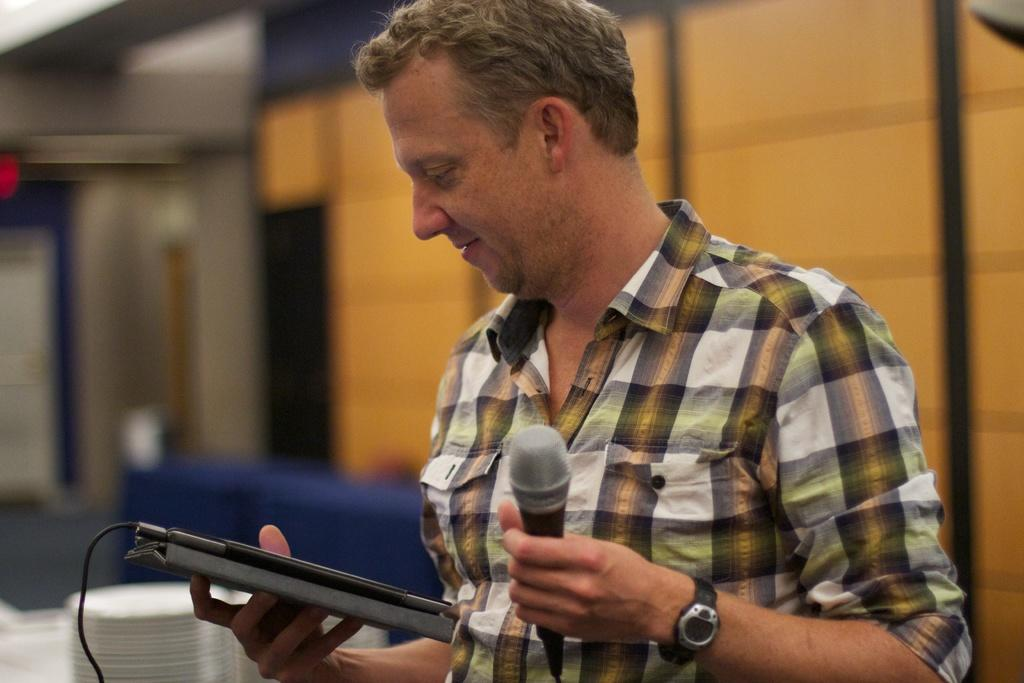What is the main subject of the image? There is a person in the image. Can you describe the person's clothing? The person is wearing a checked shirt. What is the person holding in their left hand? The person is holding a microphone in their left hand. What is the person holding in their right hand? The person is holding an electronic gadget in their right hand. What type of jewel is the person wearing around their neck in the image? There is no jewel visible around the person's neck in the image. What mode of transportation is the person planning for their upcoming trip in the image? There is no indication of a trip or mode of transportation in the image. 